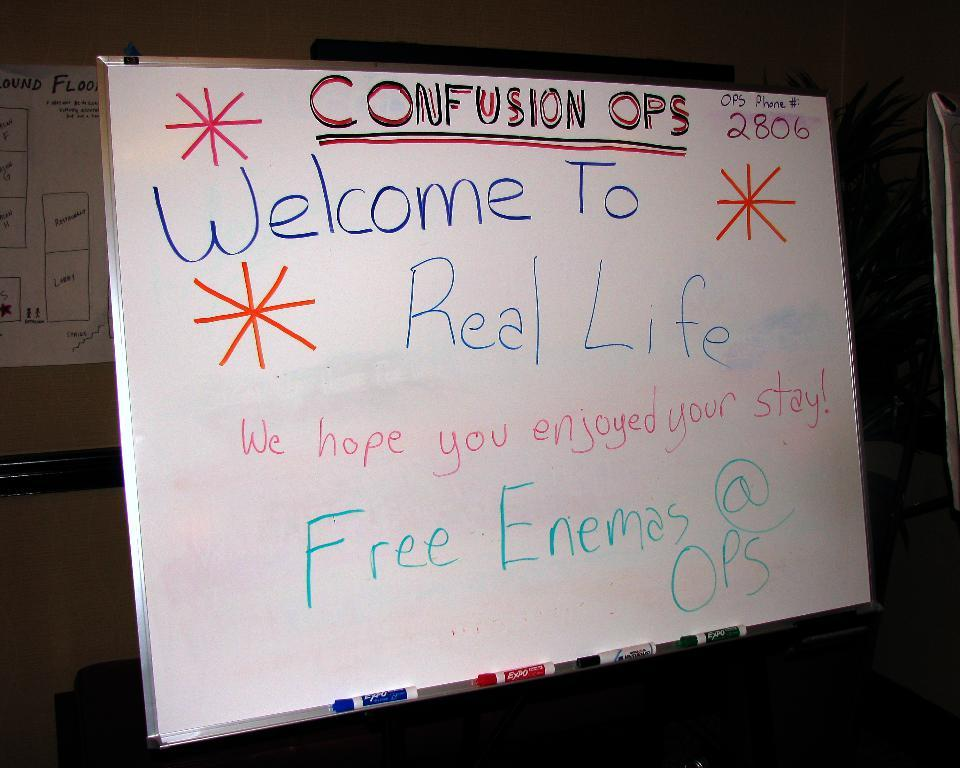<image>
Share a concise interpretation of the image provided. a poster someone wrote CONFUSION OPS "Welcome To Real Life We hope you enjoyed your stay!" Free Enamas @OPS & OPS Phone #: 2806 